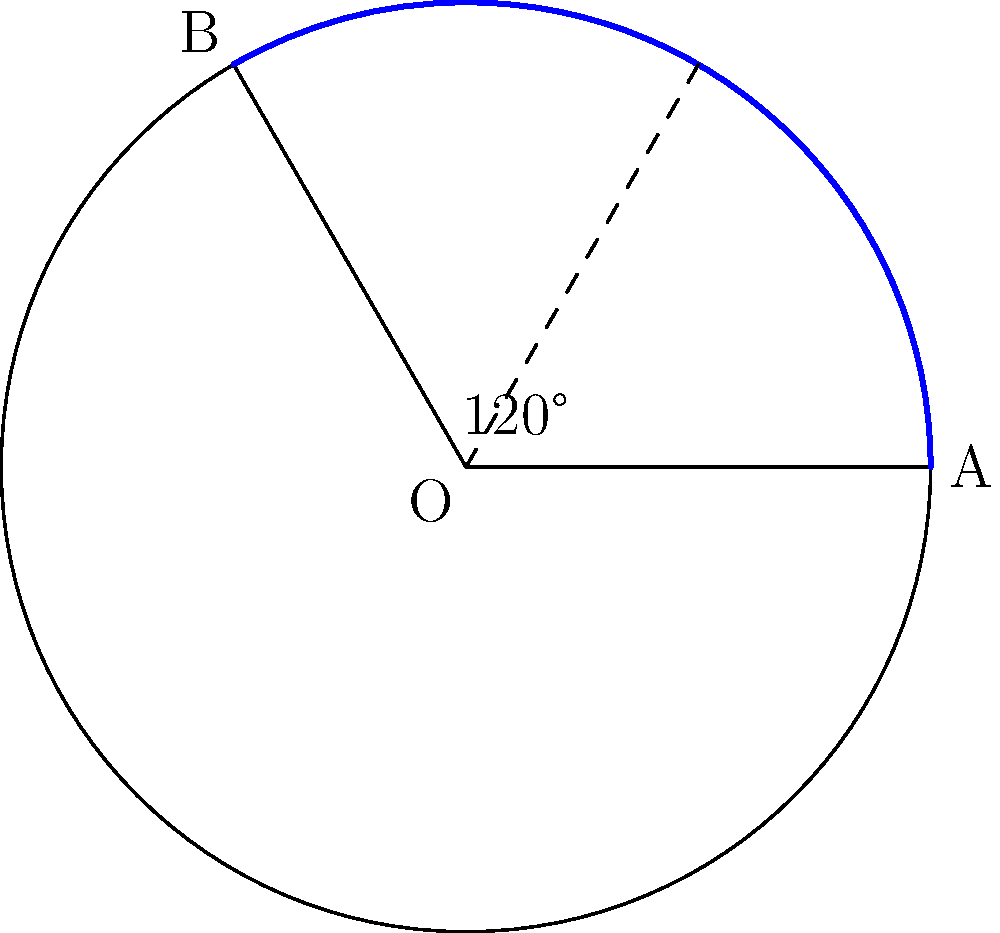A humanitarian organization is planning to distribute aid in a circular region affected by conflict. The organization can cover a sector of the region with an angle of 120° at the center. If the radius of the entire circular region is 15 km, what is the area of the sector that will receive humanitarian assistance? Round your answer to the nearest square kilometer. To solve this problem, we need to follow these steps:

1) The formula for the area of a circular sector is:
   $$A = \frac{\theta}{360°} \pi r^2$$
   where $\theta$ is the central angle in degrees, and $r$ is the radius.

2) We are given:
   $\theta = 120°$
   $r = 15$ km

3) Let's substitute these values into the formula:
   $$A = \frac{120°}{360°} \pi (15\text{ km})^2$$

4) Simplify:
   $$A = \frac{1}{3} \pi (225\text{ km}^2)$$

5) Calculate:
   $$A = 75\pi \text{ km}^2$$

6) Use $\pi \approx 3.14159$:
   $$A \approx 75 * 3.14159 \text{ km}^2 = 235.62 \text{ km}^2$$

7) Rounding to the nearest square kilometer:
   $$A \approx 236 \text{ km}^2$$

Thus, the area of the sector that will receive humanitarian assistance is approximately 236 square kilometers.
Answer: 236 km² 